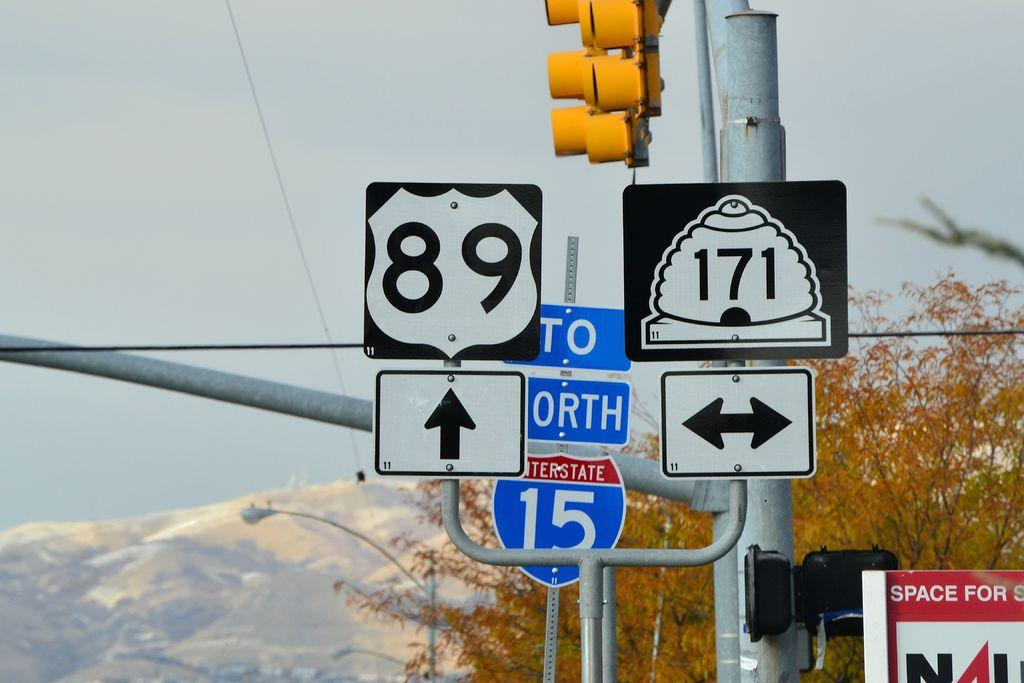<image>
Offer a succinct explanation of the picture presented. One route sign says 89 and the other says 171 